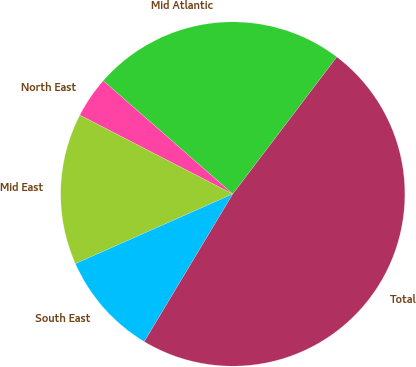<chart> <loc_0><loc_0><loc_500><loc_500><pie_chart><fcel>Mid Atlantic<fcel>North East<fcel>Mid East<fcel>South East<fcel>Total<nl><fcel>23.9%<fcel>3.86%<fcel>14.21%<fcel>9.77%<fcel>48.26%<nl></chart> 